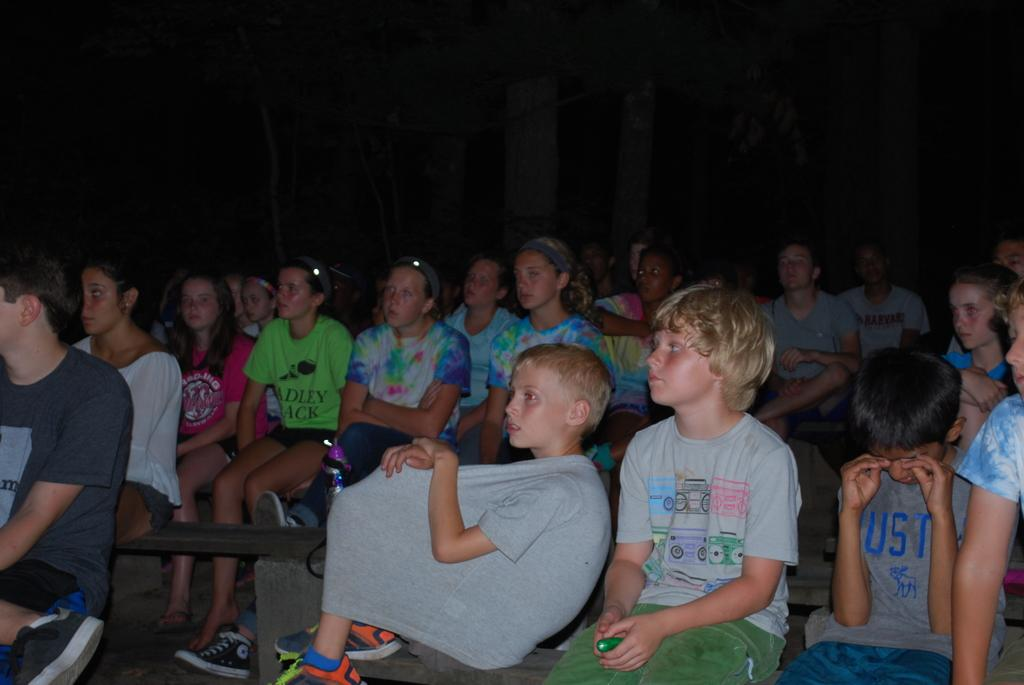What is the main subject of the image? The main subject of the image is a group of children. What are the people in the image doing? The people in the image are sitting on benches. What are the people on the benches focused on? The people are watching something. What type of iron is being used by the judge in the image? There is no judge or iron present in the image. What holiday is being celebrated in the image? There is no indication of a holiday being celebrated in the image. 